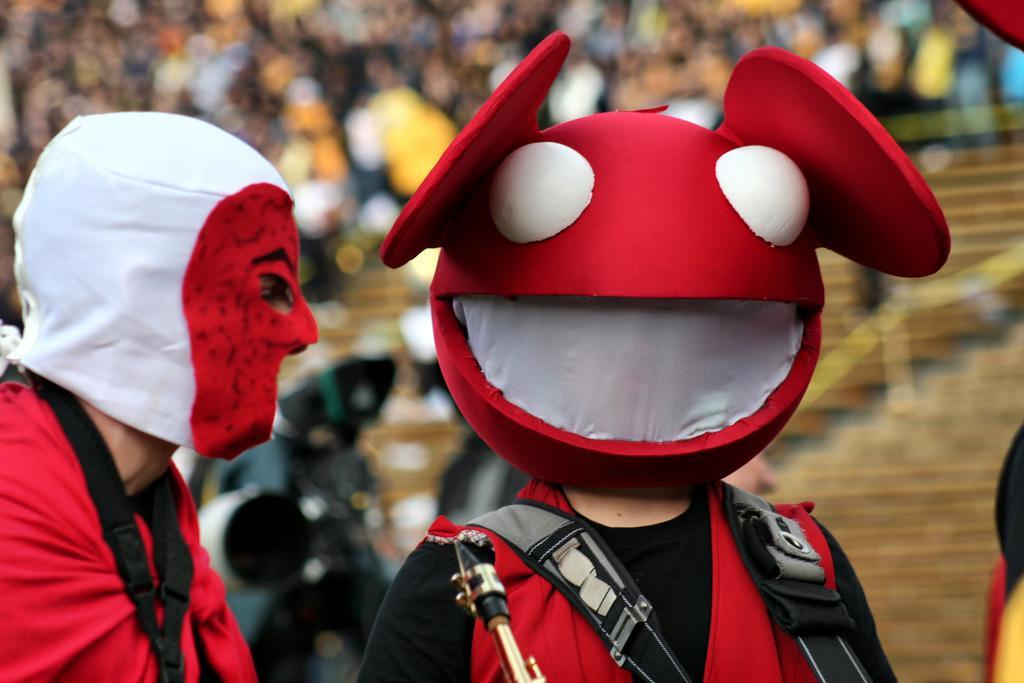Describe this image in one or two sentences. In this picture we can see two people wore costumes and in front of them we can see an object and in the background it is blurry. 